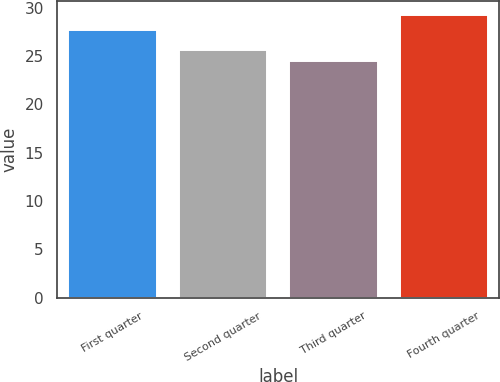<chart> <loc_0><loc_0><loc_500><loc_500><bar_chart><fcel>First quarter<fcel>Second quarter<fcel>Third quarter<fcel>Fourth quarter<nl><fcel>27.73<fcel>25.69<fcel>24.45<fcel>29.21<nl></chart> 